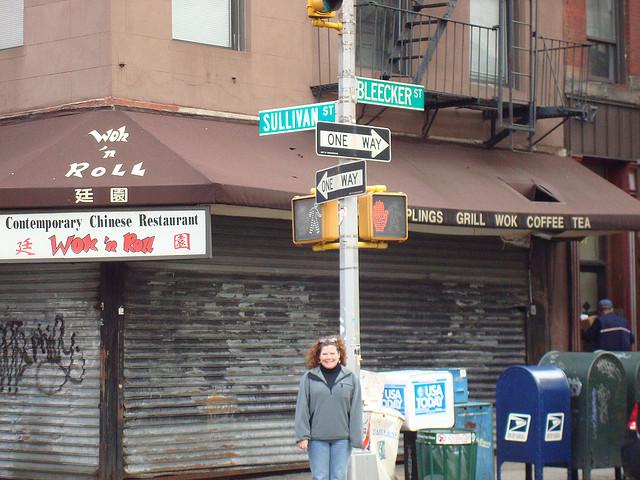Are these streets safe?
Quick response, please. No. Is there a Chinese restaurant close by?
Quick response, please. Yes. What street does Bleecker intersect with?
Quick response, please. Sullivan. 